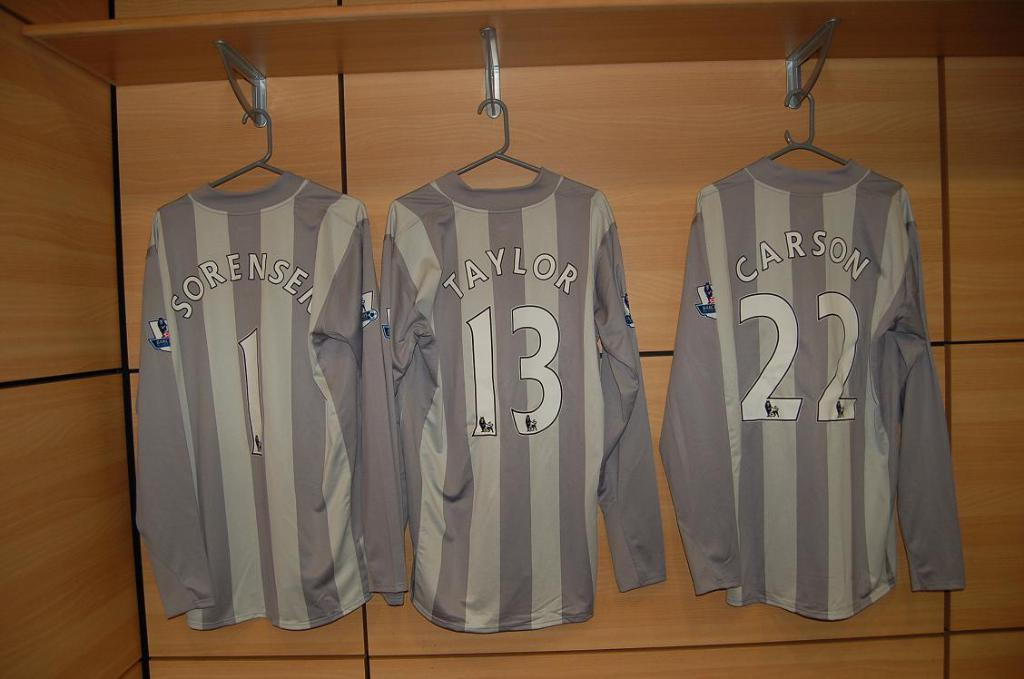<image>
Describe the image concisely. Three gray striped jerseys with the numbers 1,13 and 22 are on hangers. 